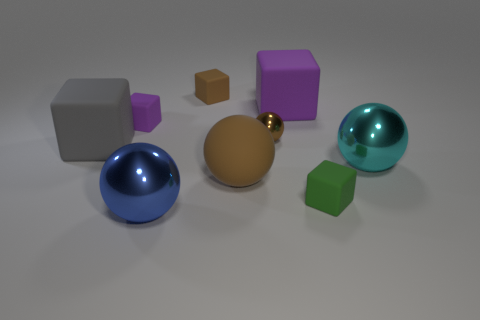Subtract all green blocks. How many blocks are left? 4 Subtract all large purple matte blocks. How many blocks are left? 4 Subtract all red blocks. Subtract all red balls. How many blocks are left? 5 Subtract all balls. How many objects are left? 5 Add 6 metal things. How many metal things are left? 9 Add 8 small green cubes. How many small green cubes exist? 9 Subtract 0 green spheres. How many objects are left? 9 Subtract all shiny spheres. Subtract all tiny purple matte objects. How many objects are left? 5 